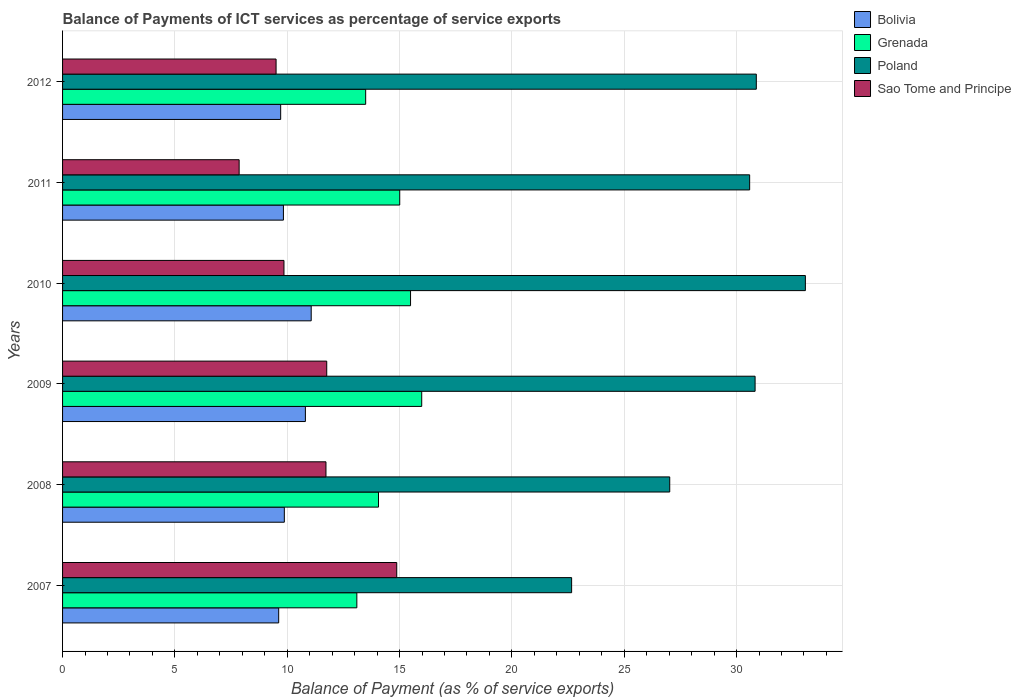How many different coloured bars are there?
Make the answer very short. 4. How many bars are there on the 2nd tick from the top?
Your answer should be compact. 4. How many bars are there on the 1st tick from the bottom?
Provide a succinct answer. 4. What is the label of the 2nd group of bars from the top?
Provide a short and direct response. 2011. In how many cases, is the number of bars for a given year not equal to the number of legend labels?
Give a very brief answer. 0. What is the balance of payments of ICT services in Grenada in 2010?
Ensure brevity in your answer.  15.49. Across all years, what is the maximum balance of payments of ICT services in Bolivia?
Ensure brevity in your answer.  11.07. Across all years, what is the minimum balance of payments of ICT services in Grenada?
Make the answer very short. 13.1. What is the total balance of payments of ICT services in Poland in the graph?
Offer a terse response. 175.03. What is the difference between the balance of payments of ICT services in Bolivia in 2007 and that in 2012?
Give a very brief answer. -0.09. What is the difference between the balance of payments of ICT services in Sao Tome and Principe in 2009 and the balance of payments of ICT services in Poland in 2011?
Provide a short and direct response. -18.82. What is the average balance of payments of ICT services in Poland per year?
Keep it short and to the point. 29.17. In the year 2008, what is the difference between the balance of payments of ICT services in Poland and balance of payments of ICT services in Bolivia?
Ensure brevity in your answer.  17.15. What is the ratio of the balance of payments of ICT services in Sao Tome and Principe in 2007 to that in 2012?
Your answer should be very brief. 1.57. Is the balance of payments of ICT services in Bolivia in 2010 less than that in 2012?
Your response must be concise. No. What is the difference between the highest and the second highest balance of payments of ICT services in Poland?
Your answer should be compact. 2.18. What is the difference between the highest and the lowest balance of payments of ICT services in Sao Tome and Principe?
Ensure brevity in your answer.  7.01. In how many years, is the balance of payments of ICT services in Poland greater than the average balance of payments of ICT services in Poland taken over all years?
Give a very brief answer. 4. What does the 1st bar from the top in 2007 represents?
Your answer should be compact. Sao Tome and Principe. What does the 2nd bar from the bottom in 2007 represents?
Offer a very short reply. Grenada. Is it the case that in every year, the sum of the balance of payments of ICT services in Poland and balance of payments of ICT services in Grenada is greater than the balance of payments of ICT services in Sao Tome and Principe?
Ensure brevity in your answer.  Yes. Does the graph contain any zero values?
Provide a succinct answer. No. Where does the legend appear in the graph?
Make the answer very short. Top right. How many legend labels are there?
Give a very brief answer. 4. What is the title of the graph?
Offer a terse response. Balance of Payments of ICT services as percentage of service exports. Does "Hong Kong" appear as one of the legend labels in the graph?
Ensure brevity in your answer.  No. What is the label or title of the X-axis?
Provide a short and direct response. Balance of Payment (as % of service exports). What is the label or title of the Y-axis?
Your answer should be compact. Years. What is the Balance of Payment (as % of service exports) in Bolivia in 2007?
Make the answer very short. 9.62. What is the Balance of Payment (as % of service exports) in Grenada in 2007?
Your answer should be very brief. 13.1. What is the Balance of Payment (as % of service exports) in Poland in 2007?
Make the answer very short. 22.66. What is the Balance of Payment (as % of service exports) in Sao Tome and Principe in 2007?
Your response must be concise. 14.87. What is the Balance of Payment (as % of service exports) of Bolivia in 2008?
Provide a succinct answer. 9.87. What is the Balance of Payment (as % of service exports) in Grenada in 2008?
Keep it short and to the point. 14.06. What is the Balance of Payment (as % of service exports) of Poland in 2008?
Provide a succinct answer. 27.02. What is the Balance of Payment (as % of service exports) of Sao Tome and Principe in 2008?
Provide a succinct answer. 11.72. What is the Balance of Payment (as % of service exports) in Bolivia in 2009?
Your response must be concise. 10.81. What is the Balance of Payment (as % of service exports) of Grenada in 2009?
Offer a terse response. 15.99. What is the Balance of Payment (as % of service exports) in Poland in 2009?
Make the answer very short. 30.82. What is the Balance of Payment (as % of service exports) in Sao Tome and Principe in 2009?
Keep it short and to the point. 11.76. What is the Balance of Payment (as % of service exports) of Bolivia in 2010?
Offer a very short reply. 11.07. What is the Balance of Payment (as % of service exports) of Grenada in 2010?
Offer a very short reply. 15.49. What is the Balance of Payment (as % of service exports) of Poland in 2010?
Your answer should be compact. 33.06. What is the Balance of Payment (as % of service exports) of Sao Tome and Principe in 2010?
Offer a very short reply. 9.85. What is the Balance of Payment (as % of service exports) in Bolivia in 2011?
Ensure brevity in your answer.  9.83. What is the Balance of Payment (as % of service exports) in Grenada in 2011?
Make the answer very short. 15.01. What is the Balance of Payment (as % of service exports) of Poland in 2011?
Your answer should be compact. 30.58. What is the Balance of Payment (as % of service exports) of Sao Tome and Principe in 2011?
Provide a short and direct response. 7.86. What is the Balance of Payment (as % of service exports) in Bolivia in 2012?
Offer a terse response. 9.71. What is the Balance of Payment (as % of service exports) in Grenada in 2012?
Your answer should be very brief. 13.49. What is the Balance of Payment (as % of service exports) of Poland in 2012?
Offer a very short reply. 30.88. What is the Balance of Payment (as % of service exports) of Sao Tome and Principe in 2012?
Keep it short and to the point. 9.5. Across all years, what is the maximum Balance of Payment (as % of service exports) in Bolivia?
Your answer should be very brief. 11.07. Across all years, what is the maximum Balance of Payment (as % of service exports) in Grenada?
Ensure brevity in your answer.  15.99. Across all years, what is the maximum Balance of Payment (as % of service exports) in Poland?
Offer a terse response. 33.06. Across all years, what is the maximum Balance of Payment (as % of service exports) in Sao Tome and Principe?
Provide a succinct answer. 14.87. Across all years, what is the minimum Balance of Payment (as % of service exports) in Bolivia?
Your response must be concise. 9.62. Across all years, what is the minimum Balance of Payment (as % of service exports) in Grenada?
Ensure brevity in your answer.  13.1. Across all years, what is the minimum Balance of Payment (as % of service exports) in Poland?
Offer a very short reply. 22.66. Across all years, what is the minimum Balance of Payment (as % of service exports) of Sao Tome and Principe?
Provide a succinct answer. 7.86. What is the total Balance of Payment (as % of service exports) in Bolivia in the graph?
Provide a succinct answer. 60.9. What is the total Balance of Payment (as % of service exports) in Grenada in the graph?
Provide a succinct answer. 87.13. What is the total Balance of Payment (as % of service exports) of Poland in the graph?
Offer a very short reply. 175.03. What is the total Balance of Payment (as % of service exports) in Sao Tome and Principe in the graph?
Offer a very short reply. 65.57. What is the difference between the Balance of Payment (as % of service exports) of Bolivia in 2007 and that in 2008?
Ensure brevity in your answer.  -0.25. What is the difference between the Balance of Payment (as % of service exports) in Grenada in 2007 and that in 2008?
Your response must be concise. -0.96. What is the difference between the Balance of Payment (as % of service exports) in Poland in 2007 and that in 2008?
Ensure brevity in your answer.  -4.37. What is the difference between the Balance of Payment (as % of service exports) of Sao Tome and Principe in 2007 and that in 2008?
Give a very brief answer. 3.15. What is the difference between the Balance of Payment (as % of service exports) in Bolivia in 2007 and that in 2009?
Provide a short and direct response. -1.19. What is the difference between the Balance of Payment (as % of service exports) of Grenada in 2007 and that in 2009?
Offer a terse response. -2.89. What is the difference between the Balance of Payment (as % of service exports) in Poland in 2007 and that in 2009?
Your answer should be compact. -8.17. What is the difference between the Balance of Payment (as % of service exports) of Sao Tome and Principe in 2007 and that in 2009?
Ensure brevity in your answer.  3.12. What is the difference between the Balance of Payment (as % of service exports) of Bolivia in 2007 and that in 2010?
Ensure brevity in your answer.  -1.45. What is the difference between the Balance of Payment (as % of service exports) of Grenada in 2007 and that in 2010?
Your answer should be compact. -2.39. What is the difference between the Balance of Payment (as % of service exports) of Poland in 2007 and that in 2010?
Give a very brief answer. -10.4. What is the difference between the Balance of Payment (as % of service exports) of Sao Tome and Principe in 2007 and that in 2010?
Give a very brief answer. 5.02. What is the difference between the Balance of Payment (as % of service exports) of Bolivia in 2007 and that in 2011?
Offer a very short reply. -0.21. What is the difference between the Balance of Payment (as % of service exports) in Grenada in 2007 and that in 2011?
Offer a very short reply. -1.91. What is the difference between the Balance of Payment (as % of service exports) in Poland in 2007 and that in 2011?
Provide a short and direct response. -7.92. What is the difference between the Balance of Payment (as % of service exports) in Sao Tome and Principe in 2007 and that in 2011?
Keep it short and to the point. 7.01. What is the difference between the Balance of Payment (as % of service exports) of Bolivia in 2007 and that in 2012?
Your answer should be compact. -0.09. What is the difference between the Balance of Payment (as % of service exports) of Grenada in 2007 and that in 2012?
Keep it short and to the point. -0.39. What is the difference between the Balance of Payment (as % of service exports) of Poland in 2007 and that in 2012?
Your answer should be compact. -8.22. What is the difference between the Balance of Payment (as % of service exports) in Sao Tome and Principe in 2007 and that in 2012?
Keep it short and to the point. 5.37. What is the difference between the Balance of Payment (as % of service exports) of Bolivia in 2008 and that in 2009?
Give a very brief answer. -0.94. What is the difference between the Balance of Payment (as % of service exports) of Grenada in 2008 and that in 2009?
Offer a terse response. -1.92. What is the difference between the Balance of Payment (as % of service exports) of Poland in 2008 and that in 2009?
Provide a succinct answer. -3.8. What is the difference between the Balance of Payment (as % of service exports) in Sao Tome and Principe in 2008 and that in 2009?
Give a very brief answer. -0.03. What is the difference between the Balance of Payment (as % of service exports) in Bolivia in 2008 and that in 2010?
Your answer should be very brief. -1.2. What is the difference between the Balance of Payment (as % of service exports) in Grenada in 2008 and that in 2010?
Your answer should be compact. -1.43. What is the difference between the Balance of Payment (as % of service exports) of Poland in 2008 and that in 2010?
Your answer should be very brief. -6.04. What is the difference between the Balance of Payment (as % of service exports) in Sao Tome and Principe in 2008 and that in 2010?
Provide a succinct answer. 1.87. What is the difference between the Balance of Payment (as % of service exports) of Bolivia in 2008 and that in 2011?
Keep it short and to the point. 0.04. What is the difference between the Balance of Payment (as % of service exports) of Grenada in 2008 and that in 2011?
Your answer should be very brief. -0.94. What is the difference between the Balance of Payment (as % of service exports) of Poland in 2008 and that in 2011?
Ensure brevity in your answer.  -3.56. What is the difference between the Balance of Payment (as % of service exports) of Sao Tome and Principe in 2008 and that in 2011?
Provide a short and direct response. 3.86. What is the difference between the Balance of Payment (as % of service exports) of Bolivia in 2008 and that in 2012?
Provide a short and direct response. 0.16. What is the difference between the Balance of Payment (as % of service exports) in Grenada in 2008 and that in 2012?
Give a very brief answer. 0.57. What is the difference between the Balance of Payment (as % of service exports) in Poland in 2008 and that in 2012?
Keep it short and to the point. -3.85. What is the difference between the Balance of Payment (as % of service exports) of Sao Tome and Principe in 2008 and that in 2012?
Provide a succinct answer. 2.22. What is the difference between the Balance of Payment (as % of service exports) in Bolivia in 2009 and that in 2010?
Your answer should be compact. -0.26. What is the difference between the Balance of Payment (as % of service exports) in Grenada in 2009 and that in 2010?
Give a very brief answer. 0.5. What is the difference between the Balance of Payment (as % of service exports) of Poland in 2009 and that in 2010?
Give a very brief answer. -2.24. What is the difference between the Balance of Payment (as % of service exports) in Sao Tome and Principe in 2009 and that in 2010?
Provide a succinct answer. 1.9. What is the difference between the Balance of Payment (as % of service exports) of Bolivia in 2009 and that in 2011?
Keep it short and to the point. 0.98. What is the difference between the Balance of Payment (as % of service exports) in Grenada in 2009 and that in 2011?
Give a very brief answer. 0.98. What is the difference between the Balance of Payment (as % of service exports) of Poland in 2009 and that in 2011?
Your answer should be compact. 0.24. What is the difference between the Balance of Payment (as % of service exports) of Sao Tome and Principe in 2009 and that in 2011?
Provide a short and direct response. 3.9. What is the difference between the Balance of Payment (as % of service exports) of Bolivia in 2009 and that in 2012?
Your response must be concise. 1.1. What is the difference between the Balance of Payment (as % of service exports) of Grenada in 2009 and that in 2012?
Offer a very short reply. 2.49. What is the difference between the Balance of Payment (as % of service exports) of Poland in 2009 and that in 2012?
Provide a succinct answer. -0.05. What is the difference between the Balance of Payment (as % of service exports) of Sao Tome and Principe in 2009 and that in 2012?
Make the answer very short. 2.25. What is the difference between the Balance of Payment (as % of service exports) in Bolivia in 2010 and that in 2011?
Your answer should be compact. 1.24. What is the difference between the Balance of Payment (as % of service exports) of Grenada in 2010 and that in 2011?
Your answer should be compact. 0.48. What is the difference between the Balance of Payment (as % of service exports) of Poland in 2010 and that in 2011?
Provide a succinct answer. 2.48. What is the difference between the Balance of Payment (as % of service exports) of Sao Tome and Principe in 2010 and that in 2011?
Ensure brevity in your answer.  1.99. What is the difference between the Balance of Payment (as % of service exports) of Bolivia in 2010 and that in 2012?
Offer a very short reply. 1.36. What is the difference between the Balance of Payment (as % of service exports) in Grenada in 2010 and that in 2012?
Offer a terse response. 2. What is the difference between the Balance of Payment (as % of service exports) in Poland in 2010 and that in 2012?
Keep it short and to the point. 2.18. What is the difference between the Balance of Payment (as % of service exports) of Sao Tome and Principe in 2010 and that in 2012?
Give a very brief answer. 0.35. What is the difference between the Balance of Payment (as % of service exports) of Bolivia in 2011 and that in 2012?
Ensure brevity in your answer.  0.12. What is the difference between the Balance of Payment (as % of service exports) in Grenada in 2011 and that in 2012?
Provide a short and direct response. 1.52. What is the difference between the Balance of Payment (as % of service exports) of Poland in 2011 and that in 2012?
Your answer should be very brief. -0.3. What is the difference between the Balance of Payment (as % of service exports) in Sao Tome and Principe in 2011 and that in 2012?
Your response must be concise. -1.64. What is the difference between the Balance of Payment (as % of service exports) of Bolivia in 2007 and the Balance of Payment (as % of service exports) of Grenada in 2008?
Keep it short and to the point. -4.44. What is the difference between the Balance of Payment (as % of service exports) of Bolivia in 2007 and the Balance of Payment (as % of service exports) of Poland in 2008?
Ensure brevity in your answer.  -17.4. What is the difference between the Balance of Payment (as % of service exports) of Bolivia in 2007 and the Balance of Payment (as % of service exports) of Sao Tome and Principe in 2008?
Offer a very short reply. -2.1. What is the difference between the Balance of Payment (as % of service exports) in Grenada in 2007 and the Balance of Payment (as % of service exports) in Poland in 2008?
Your answer should be compact. -13.93. What is the difference between the Balance of Payment (as % of service exports) of Grenada in 2007 and the Balance of Payment (as % of service exports) of Sao Tome and Principe in 2008?
Make the answer very short. 1.37. What is the difference between the Balance of Payment (as % of service exports) in Poland in 2007 and the Balance of Payment (as % of service exports) in Sao Tome and Principe in 2008?
Your response must be concise. 10.93. What is the difference between the Balance of Payment (as % of service exports) of Bolivia in 2007 and the Balance of Payment (as % of service exports) of Grenada in 2009?
Ensure brevity in your answer.  -6.37. What is the difference between the Balance of Payment (as % of service exports) of Bolivia in 2007 and the Balance of Payment (as % of service exports) of Poland in 2009?
Your answer should be compact. -21.2. What is the difference between the Balance of Payment (as % of service exports) in Bolivia in 2007 and the Balance of Payment (as % of service exports) in Sao Tome and Principe in 2009?
Make the answer very short. -2.14. What is the difference between the Balance of Payment (as % of service exports) of Grenada in 2007 and the Balance of Payment (as % of service exports) of Poland in 2009?
Your response must be concise. -17.73. What is the difference between the Balance of Payment (as % of service exports) in Grenada in 2007 and the Balance of Payment (as % of service exports) in Sao Tome and Principe in 2009?
Your answer should be very brief. 1.34. What is the difference between the Balance of Payment (as % of service exports) of Poland in 2007 and the Balance of Payment (as % of service exports) of Sao Tome and Principe in 2009?
Offer a very short reply. 10.9. What is the difference between the Balance of Payment (as % of service exports) in Bolivia in 2007 and the Balance of Payment (as % of service exports) in Grenada in 2010?
Ensure brevity in your answer.  -5.87. What is the difference between the Balance of Payment (as % of service exports) in Bolivia in 2007 and the Balance of Payment (as % of service exports) in Poland in 2010?
Offer a very short reply. -23.44. What is the difference between the Balance of Payment (as % of service exports) of Bolivia in 2007 and the Balance of Payment (as % of service exports) of Sao Tome and Principe in 2010?
Offer a very short reply. -0.23. What is the difference between the Balance of Payment (as % of service exports) in Grenada in 2007 and the Balance of Payment (as % of service exports) in Poland in 2010?
Make the answer very short. -19.96. What is the difference between the Balance of Payment (as % of service exports) of Grenada in 2007 and the Balance of Payment (as % of service exports) of Sao Tome and Principe in 2010?
Give a very brief answer. 3.24. What is the difference between the Balance of Payment (as % of service exports) in Poland in 2007 and the Balance of Payment (as % of service exports) in Sao Tome and Principe in 2010?
Offer a terse response. 12.8. What is the difference between the Balance of Payment (as % of service exports) of Bolivia in 2007 and the Balance of Payment (as % of service exports) of Grenada in 2011?
Ensure brevity in your answer.  -5.39. What is the difference between the Balance of Payment (as % of service exports) in Bolivia in 2007 and the Balance of Payment (as % of service exports) in Poland in 2011?
Keep it short and to the point. -20.96. What is the difference between the Balance of Payment (as % of service exports) of Bolivia in 2007 and the Balance of Payment (as % of service exports) of Sao Tome and Principe in 2011?
Make the answer very short. 1.76. What is the difference between the Balance of Payment (as % of service exports) in Grenada in 2007 and the Balance of Payment (as % of service exports) in Poland in 2011?
Provide a short and direct response. -17.48. What is the difference between the Balance of Payment (as % of service exports) in Grenada in 2007 and the Balance of Payment (as % of service exports) in Sao Tome and Principe in 2011?
Offer a terse response. 5.24. What is the difference between the Balance of Payment (as % of service exports) in Poland in 2007 and the Balance of Payment (as % of service exports) in Sao Tome and Principe in 2011?
Keep it short and to the point. 14.8. What is the difference between the Balance of Payment (as % of service exports) in Bolivia in 2007 and the Balance of Payment (as % of service exports) in Grenada in 2012?
Give a very brief answer. -3.87. What is the difference between the Balance of Payment (as % of service exports) in Bolivia in 2007 and the Balance of Payment (as % of service exports) in Poland in 2012?
Give a very brief answer. -21.26. What is the difference between the Balance of Payment (as % of service exports) in Bolivia in 2007 and the Balance of Payment (as % of service exports) in Sao Tome and Principe in 2012?
Offer a very short reply. 0.12. What is the difference between the Balance of Payment (as % of service exports) in Grenada in 2007 and the Balance of Payment (as % of service exports) in Poland in 2012?
Offer a terse response. -17.78. What is the difference between the Balance of Payment (as % of service exports) of Grenada in 2007 and the Balance of Payment (as % of service exports) of Sao Tome and Principe in 2012?
Give a very brief answer. 3.59. What is the difference between the Balance of Payment (as % of service exports) of Poland in 2007 and the Balance of Payment (as % of service exports) of Sao Tome and Principe in 2012?
Keep it short and to the point. 13.15. What is the difference between the Balance of Payment (as % of service exports) in Bolivia in 2008 and the Balance of Payment (as % of service exports) in Grenada in 2009?
Your answer should be very brief. -6.12. What is the difference between the Balance of Payment (as % of service exports) of Bolivia in 2008 and the Balance of Payment (as % of service exports) of Poland in 2009?
Keep it short and to the point. -20.95. What is the difference between the Balance of Payment (as % of service exports) of Bolivia in 2008 and the Balance of Payment (as % of service exports) of Sao Tome and Principe in 2009?
Offer a terse response. -1.89. What is the difference between the Balance of Payment (as % of service exports) of Grenada in 2008 and the Balance of Payment (as % of service exports) of Poland in 2009?
Provide a succinct answer. -16.76. What is the difference between the Balance of Payment (as % of service exports) of Grenada in 2008 and the Balance of Payment (as % of service exports) of Sao Tome and Principe in 2009?
Provide a succinct answer. 2.3. What is the difference between the Balance of Payment (as % of service exports) of Poland in 2008 and the Balance of Payment (as % of service exports) of Sao Tome and Principe in 2009?
Make the answer very short. 15.27. What is the difference between the Balance of Payment (as % of service exports) in Bolivia in 2008 and the Balance of Payment (as % of service exports) in Grenada in 2010?
Keep it short and to the point. -5.62. What is the difference between the Balance of Payment (as % of service exports) of Bolivia in 2008 and the Balance of Payment (as % of service exports) of Poland in 2010?
Keep it short and to the point. -23.19. What is the difference between the Balance of Payment (as % of service exports) of Bolivia in 2008 and the Balance of Payment (as % of service exports) of Sao Tome and Principe in 2010?
Offer a very short reply. 0.02. What is the difference between the Balance of Payment (as % of service exports) in Grenada in 2008 and the Balance of Payment (as % of service exports) in Poland in 2010?
Your answer should be compact. -19. What is the difference between the Balance of Payment (as % of service exports) of Grenada in 2008 and the Balance of Payment (as % of service exports) of Sao Tome and Principe in 2010?
Provide a succinct answer. 4.21. What is the difference between the Balance of Payment (as % of service exports) in Poland in 2008 and the Balance of Payment (as % of service exports) in Sao Tome and Principe in 2010?
Provide a succinct answer. 17.17. What is the difference between the Balance of Payment (as % of service exports) of Bolivia in 2008 and the Balance of Payment (as % of service exports) of Grenada in 2011?
Keep it short and to the point. -5.14. What is the difference between the Balance of Payment (as % of service exports) of Bolivia in 2008 and the Balance of Payment (as % of service exports) of Poland in 2011?
Provide a short and direct response. -20.71. What is the difference between the Balance of Payment (as % of service exports) in Bolivia in 2008 and the Balance of Payment (as % of service exports) in Sao Tome and Principe in 2011?
Offer a very short reply. 2.01. What is the difference between the Balance of Payment (as % of service exports) in Grenada in 2008 and the Balance of Payment (as % of service exports) in Poland in 2011?
Your response must be concise. -16.52. What is the difference between the Balance of Payment (as % of service exports) in Grenada in 2008 and the Balance of Payment (as % of service exports) in Sao Tome and Principe in 2011?
Give a very brief answer. 6.2. What is the difference between the Balance of Payment (as % of service exports) of Poland in 2008 and the Balance of Payment (as % of service exports) of Sao Tome and Principe in 2011?
Your answer should be compact. 19.17. What is the difference between the Balance of Payment (as % of service exports) in Bolivia in 2008 and the Balance of Payment (as % of service exports) in Grenada in 2012?
Offer a very short reply. -3.62. What is the difference between the Balance of Payment (as % of service exports) of Bolivia in 2008 and the Balance of Payment (as % of service exports) of Poland in 2012?
Your answer should be compact. -21.01. What is the difference between the Balance of Payment (as % of service exports) of Bolivia in 2008 and the Balance of Payment (as % of service exports) of Sao Tome and Principe in 2012?
Ensure brevity in your answer.  0.37. What is the difference between the Balance of Payment (as % of service exports) of Grenada in 2008 and the Balance of Payment (as % of service exports) of Poland in 2012?
Keep it short and to the point. -16.82. What is the difference between the Balance of Payment (as % of service exports) of Grenada in 2008 and the Balance of Payment (as % of service exports) of Sao Tome and Principe in 2012?
Offer a terse response. 4.56. What is the difference between the Balance of Payment (as % of service exports) of Poland in 2008 and the Balance of Payment (as % of service exports) of Sao Tome and Principe in 2012?
Provide a short and direct response. 17.52. What is the difference between the Balance of Payment (as % of service exports) of Bolivia in 2009 and the Balance of Payment (as % of service exports) of Grenada in 2010?
Your answer should be very brief. -4.68. What is the difference between the Balance of Payment (as % of service exports) of Bolivia in 2009 and the Balance of Payment (as % of service exports) of Poland in 2010?
Provide a short and direct response. -22.25. What is the difference between the Balance of Payment (as % of service exports) in Bolivia in 2009 and the Balance of Payment (as % of service exports) in Sao Tome and Principe in 2010?
Keep it short and to the point. 0.95. What is the difference between the Balance of Payment (as % of service exports) of Grenada in 2009 and the Balance of Payment (as % of service exports) of Poland in 2010?
Your answer should be very brief. -17.08. What is the difference between the Balance of Payment (as % of service exports) of Grenada in 2009 and the Balance of Payment (as % of service exports) of Sao Tome and Principe in 2010?
Offer a terse response. 6.13. What is the difference between the Balance of Payment (as % of service exports) in Poland in 2009 and the Balance of Payment (as % of service exports) in Sao Tome and Principe in 2010?
Ensure brevity in your answer.  20.97. What is the difference between the Balance of Payment (as % of service exports) in Bolivia in 2009 and the Balance of Payment (as % of service exports) in Grenada in 2011?
Your answer should be compact. -4.2. What is the difference between the Balance of Payment (as % of service exports) in Bolivia in 2009 and the Balance of Payment (as % of service exports) in Poland in 2011?
Provide a short and direct response. -19.77. What is the difference between the Balance of Payment (as % of service exports) in Bolivia in 2009 and the Balance of Payment (as % of service exports) in Sao Tome and Principe in 2011?
Keep it short and to the point. 2.95. What is the difference between the Balance of Payment (as % of service exports) of Grenada in 2009 and the Balance of Payment (as % of service exports) of Poland in 2011?
Your answer should be very brief. -14.6. What is the difference between the Balance of Payment (as % of service exports) in Grenada in 2009 and the Balance of Payment (as % of service exports) in Sao Tome and Principe in 2011?
Your answer should be very brief. 8.13. What is the difference between the Balance of Payment (as % of service exports) in Poland in 2009 and the Balance of Payment (as % of service exports) in Sao Tome and Principe in 2011?
Keep it short and to the point. 22.96. What is the difference between the Balance of Payment (as % of service exports) of Bolivia in 2009 and the Balance of Payment (as % of service exports) of Grenada in 2012?
Provide a succinct answer. -2.68. What is the difference between the Balance of Payment (as % of service exports) in Bolivia in 2009 and the Balance of Payment (as % of service exports) in Poland in 2012?
Offer a terse response. -20.07. What is the difference between the Balance of Payment (as % of service exports) in Bolivia in 2009 and the Balance of Payment (as % of service exports) in Sao Tome and Principe in 2012?
Offer a terse response. 1.3. What is the difference between the Balance of Payment (as % of service exports) of Grenada in 2009 and the Balance of Payment (as % of service exports) of Poland in 2012?
Provide a short and direct response. -14.89. What is the difference between the Balance of Payment (as % of service exports) of Grenada in 2009 and the Balance of Payment (as % of service exports) of Sao Tome and Principe in 2012?
Make the answer very short. 6.48. What is the difference between the Balance of Payment (as % of service exports) of Poland in 2009 and the Balance of Payment (as % of service exports) of Sao Tome and Principe in 2012?
Ensure brevity in your answer.  21.32. What is the difference between the Balance of Payment (as % of service exports) of Bolivia in 2010 and the Balance of Payment (as % of service exports) of Grenada in 2011?
Your response must be concise. -3.94. What is the difference between the Balance of Payment (as % of service exports) in Bolivia in 2010 and the Balance of Payment (as % of service exports) in Poland in 2011?
Provide a succinct answer. -19.52. What is the difference between the Balance of Payment (as % of service exports) of Bolivia in 2010 and the Balance of Payment (as % of service exports) of Sao Tome and Principe in 2011?
Ensure brevity in your answer.  3.21. What is the difference between the Balance of Payment (as % of service exports) in Grenada in 2010 and the Balance of Payment (as % of service exports) in Poland in 2011?
Ensure brevity in your answer.  -15.09. What is the difference between the Balance of Payment (as % of service exports) of Grenada in 2010 and the Balance of Payment (as % of service exports) of Sao Tome and Principe in 2011?
Provide a short and direct response. 7.63. What is the difference between the Balance of Payment (as % of service exports) of Poland in 2010 and the Balance of Payment (as % of service exports) of Sao Tome and Principe in 2011?
Provide a short and direct response. 25.2. What is the difference between the Balance of Payment (as % of service exports) in Bolivia in 2010 and the Balance of Payment (as % of service exports) in Grenada in 2012?
Provide a short and direct response. -2.42. What is the difference between the Balance of Payment (as % of service exports) in Bolivia in 2010 and the Balance of Payment (as % of service exports) in Poland in 2012?
Offer a terse response. -19.81. What is the difference between the Balance of Payment (as % of service exports) of Bolivia in 2010 and the Balance of Payment (as % of service exports) of Sao Tome and Principe in 2012?
Your answer should be very brief. 1.56. What is the difference between the Balance of Payment (as % of service exports) of Grenada in 2010 and the Balance of Payment (as % of service exports) of Poland in 2012?
Provide a short and direct response. -15.39. What is the difference between the Balance of Payment (as % of service exports) of Grenada in 2010 and the Balance of Payment (as % of service exports) of Sao Tome and Principe in 2012?
Offer a terse response. 5.98. What is the difference between the Balance of Payment (as % of service exports) in Poland in 2010 and the Balance of Payment (as % of service exports) in Sao Tome and Principe in 2012?
Your answer should be compact. 23.56. What is the difference between the Balance of Payment (as % of service exports) in Bolivia in 2011 and the Balance of Payment (as % of service exports) in Grenada in 2012?
Your answer should be very brief. -3.66. What is the difference between the Balance of Payment (as % of service exports) of Bolivia in 2011 and the Balance of Payment (as % of service exports) of Poland in 2012?
Provide a short and direct response. -21.05. What is the difference between the Balance of Payment (as % of service exports) of Bolivia in 2011 and the Balance of Payment (as % of service exports) of Sao Tome and Principe in 2012?
Give a very brief answer. 0.33. What is the difference between the Balance of Payment (as % of service exports) in Grenada in 2011 and the Balance of Payment (as % of service exports) in Poland in 2012?
Keep it short and to the point. -15.87. What is the difference between the Balance of Payment (as % of service exports) of Grenada in 2011 and the Balance of Payment (as % of service exports) of Sao Tome and Principe in 2012?
Provide a short and direct response. 5.5. What is the difference between the Balance of Payment (as % of service exports) of Poland in 2011 and the Balance of Payment (as % of service exports) of Sao Tome and Principe in 2012?
Your response must be concise. 21.08. What is the average Balance of Payment (as % of service exports) of Bolivia per year?
Provide a succinct answer. 10.15. What is the average Balance of Payment (as % of service exports) of Grenada per year?
Give a very brief answer. 14.52. What is the average Balance of Payment (as % of service exports) of Poland per year?
Keep it short and to the point. 29.17. What is the average Balance of Payment (as % of service exports) of Sao Tome and Principe per year?
Provide a short and direct response. 10.93. In the year 2007, what is the difference between the Balance of Payment (as % of service exports) in Bolivia and Balance of Payment (as % of service exports) in Grenada?
Make the answer very short. -3.48. In the year 2007, what is the difference between the Balance of Payment (as % of service exports) of Bolivia and Balance of Payment (as % of service exports) of Poland?
Offer a terse response. -13.04. In the year 2007, what is the difference between the Balance of Payment (as % of service exports) in Bolivia and Balance of Payment (as % of service exports) in Sao Tome and Principe?
Ensure brevity in your answer.  -5.25. In the year 2007, what is the difference between the Balance of Payment (as % of service exports) of Grenada and Balance of Payment (as % of service exports) of Poland?
Ensure brevity in your answer.  -9.56. In the year 2007, what is the difference between the Balance of Payment (as % of service exports) in Grenada and Balance of Payment (as % of service exports) in Sao Tome and Principe?
Make the answer very short. -1.77. In the year 2007, what is the difference between the Balance of Payment (as % of service exports) of Poland and Balance of Payment (as % of service exports) of Sao Tome and Principe?
Offer a very short reply. 7.79. In the year 2008, what is the difference between the Balance of Payment (as % of service exports) of Bolivia and Balance of Payment (as % of service exports) of Grenada?
Keep it short and to the point. -4.19. In the year 2008, what is the difference between the Balance of Payment (as % of service exports) of Bolivia and Balance of Payment (as % of service exports) of Poland?
Provide a short and direct response. -17.15. In the year 2008, what is the difference between the Balance of Payment (as % of service exports) of Bolivia and Balance of Payment (as % of service exports) of Sao Tome and Principe?
Give a very brief answer. -1.85. In the year 2008, what is the difference between the Balance of Payment (as % of service exports) of Grenada and Balance of Payment (as % of service exports) of Poland?
Your answer should be very brief. -12.96. In the year 2008, what is the difference between the Balance of Payment (as % of service exports) of Grenada and Balance of Payment (as % of service exports) of Sao Tome and Principe?
Your answer should be compact. 2.34. In the year 2008, what is the difference between the Balance of Payment (as % of service exports) in Poland and Balance of Payment (as % of service exports) in Sao Tome and Principe?
Your answer should be very brief. 15.3. In the year 2009, what is the difference between the Balance of Payment (as % of service exports) in Bolivia and Balance of Payment (as % of service exports) in Grenada?
Offer a very short reply. -5.18. In the year 2009, what is the difference between the Balance of Payment (as % of service exports) of Bolivia and Balance of Payment (as % of service exports) of Poland?
Your answer should be very brief. -20.02. In the year 2009, what is the difference between the Balance of Payment (as % of service exports) in Bolivia and Balance of Payment (as % of service exports) in Sao Tome and Principe?
Offer a very short reply. -0.95. In the year 2009, what is the difference between the Balance of Payment (as % of service exports) in Grenada and Balance of Payment (as % of service exports) in Poland?
Make the answer very short. -14.84. In the year 2009, what is the difference between the Balance of Payment (as % of service exports) of Grenada and Balance of Payment (as % of service exports) of Sao Tome and Principe?
Your response must be concise. 4.23. In the year 2009, what is the difference between the Balance of Payment (as % of service exports) in Poland and Balance of Payment (as % of service exports) in Sao Tome and Principe?
Provide a succinct answer. 19.07. In the year 2010, what is the difference between the Balance of Payment (as % of service exports) of Bolivia and Balance of Payment (as % of service exports) of Grenada?
Provide a short and direct response. -4.42. In the year 2010, what is the difference between the Balance of Payment (as % of service exports) in Bolivia and Balance of Payment (as % of service exports) in Poland?
Make the answer very short. -21.99. In the year 2010, what is the difference between the Balance of Payment (as % of service exports) of Bolivia and Balance of Payment (as % of service exports) of Sao Tome and Principe?
Provide a succinct answer. 1.21. In the year 2010, what is the difference between the Balance of Payment (as % of service exports) in Grenada and Balance of Payment (as % of service exports) in Poland?
Keep it short and to the point. -17.57. In the year 2010, what is the difference between the Balance of Payment (as % of service exports) in Grenada and Balance of Payment (as % of service exports) in Sao Tome and Principe?
Your response must be concise. 5.63. In the year 2010, what is the difference between the Balance of Payment (as % of service exports) in Poland and Balance of Payment (as % of service exports) in Sao Tome and Principe?
Your response must be concise. 23.21. In the year 2011, what is the difference between the Balance of Payment (as % of service exports) in Bolivia and Balance of Payment (as % of service exports) in Grenada?
Provide a succinct answer. -5.18. In the year 2011, what is the difference between the Balance of Payment (as % of service exports) of Bolivia and Balance of Payment (as % of service exports) of Poland?
Offer a very short reply. -20.75. In the year 2011, what is the difference between the Balance of Payment (as % of service exports) in Bolivia and Balance of Payment (as % of service exports) in Sao Tome and Principe?
Offer a terse response. 1.97. In the year 2011, what is the difference between the Balance of Payment (as % of service exports) in Grenada and Balance of Payment (as % of service exports) in Poland?
Give a very brief answer. -15.57. In the year 2011, what is the difference between the Balance of Payment (as % of service exports) of Grenada and Balance of Payment (as % of service exports) of Sao Tome and Principe?
Offer a terse response. 7.15. In the year 2011, what is the difference between the Balance of Payment (as % of service exports) in Poland and Balance of Payment (as % of service exports) in Sao Tome and Principe?
Provide a short and direct response. 22.72. In the year 2012, what is the difference between the Balance of Payment (as % of service exports) in Bolivia and Balance of Payment (as % of service exports) in Grenada?
Your response must be concise. -3.78. In the year 2012, what is the difference between the Balance of Payment (as % of service exports) in Bolivia and Balance of Payment (as % of service exports) in Poland?
Make the answer very short. -21.17. In the year 2012, what is the difference between the Balance of Payment (as % of service exports) of Bolivia and Balance of Payment (as % of service exports) of Sao Tome and Principe?
Offer a terse response. 0.2. In the year 2012, what is the difference between the Balance of Payment (as % of service exports) in Grenada and Balance of Payment (as % of service exports) in Poland?
Ensure brevity in your answer.  -17.39. In the year 2012, what is the difference between the Balance of Payment (as % of service exports) of Grenada and Balance of Payment (as % of service exports) of Sao Tome and Principe?
Provide a succinct answer. 3.99. In the year 2012, what is the difference between the Balance of Payment (as % of service exports) of Poland and Balance of Payment (as % of service exports) of Sao Tome and Principe?
Your answer should be compact. 21.37. What is the ratio of the Balance of Payment (as % of service exports) of Bolivia in 2007 to that in 2008?
Provide a short and direct response. 0.97. What is the ratio of the Balance of Payment (as % of service exports) of Grenada in 2007 to that in 2008?
Make the answer very short. 0.93. What is the ratio of the Balance of Payment (as % of service exports) of Poland in 2007 to that in 2008?
Give a very brief answer. 0.84. What is the ratio of the Balance of Payment (as % of service exports) in Sao Tome and Principe in 2007 to that in 2008?
Provide a succinct answer. 1.27. What is the ratio of the Balance of Payment (as % of service exports) in Bolivia in 2007 to that in 2009?
Keep it short and to the point. 0.89. What is the ratio of the Balance of Payment (as % of service exports) of Grenada in 2007 to that in 2009?
Your response must be concise. 0.82. What is the ratio of the Balance of Payment (as % of service exports) of Poland in 2007 to that in 2009?
Keep it short and to the point. 0.74. What is the ratio of the Balance of Payment (as % of service exports) in Sao Tome and Principe in 2007 to that in 2009?
Your answer should be compact. 1.26. What is the ratio of the Balance of Payment (as % of service exports) of Bolivia in 2007 to that in 2010?
Ensure brevity in your answer.  0.87. What is the ratio of the Balance of Payment (as % of service exports) of Grenada in 2007 to that in 2010?
Make the answer very short. 0.85. What is the ratio of the Balance of Payment (as % of service exports) of Poland in 2007 to that in 2010?
Your response must be concise. 0.69. What is the ratio of the Balance of Payment (as % of service exports) of Sao Tome and Principe in 2007 to that in 2010?
Keep it short and to the point. 1.51. What is the ratio of the Balance of Payment (as % of service exports) in Bolivia in 2007 to that in 2011?
Give a very brief answer. 0.98. What is the ratio of the Balance of Payment (as % of service exports) in Grenada in 2007 to that in 2011?
Offer a terse response. 0.87. What is the ratio of the Balance of Payment (as % of service exports) in Poland in 2007 to that in 2011?
Make the answer very short. 0.74. What is the ratio of the Balance of Payment (as % of service exports) in Sao Tome and Principe in 2007 to that in 2011?
Offer a very short reply. 1.89. What is the ratio of the Balance of Payment (as % of service exports) of Bolivia in 2007 to that in 2012?
Give a very brief answer. 0.99. What is the ratio of the Balance of Payment (as % of service exports) of Grenada in 2007 to that in 2012?
Your response must be concise. 0.97. What is the ratio of the Balance of Payment (as % of service exports) of Poland in 2007 to that in 2012?
Your answer should be compact. 0.73. What is the ratio of the Balance of Payment (as % of service exports) of Sao Tome and Principe in 2007 to that in 2012?
Your response must be concise. 1.56. What is the ratio of the Balance of Payment (as % of service exports) of Bolivia in 2008 to that in 2009?
Your answer should be compact. 0.91. What is the ratio of the Balance of Payment (as % of service exports) of Grenada in 2008 to that in 2009?
Keep it short and to the point. 0.88. What is the ratio of the Balance of Payment (as % of service exports) of Poland in 2008 to that in 2009?
Ensure brevity in your answer.  0.88. What is the ratio of the Balance of Payment (as % of service exports) of Sao Tome and Principe in 2008 to that in 2009?
Give a very brief answer. 1. What is the ratio of the Balance of Payment (as % of service exports) in Bolivia in 2008 to that in 2010?
Your response must be concise. 0.89. What is the ratio of the Balance of Payment (as % of service exports) in Grenada in 2008 to that in 2010?
Offer a terse response. 0.91. What is the ratio of the Balance of Payment (as % of service exports) of Poland in 2008 to that in 2010?
Offer a very short reply. 0.82. What is the ratio of the Balance of Payment (as % of service exports) in Sao Tome and Principe in 2008 to that in 2010?
Give a very brief answer. 1.19. What is the ratio of the Balance of Payment (as % of service exports) of Grenada in 2008 to that in 2011?
Your answer should be compact. 0.94. What is the ratio of the Balance of Payment (as % of service exports) in Poland in 2008 to that in 2011?
Offer a very short reply. 0.88. What is the ratio of the Balance of Payment (as % of service exports) of Sao Tome and Principe in 2008 to that in 2011?
Keep it short and to the point. 1.49. What is the ratio of the Balance of Payment (as % of service exports) in Bolivia in 2008 to that in 2012?
Your answer should be compact. 1.02. What is the ratio of the Balance of Payment (as % of service exports) in Grenada in 2008 to that in 2012?
Your response must be concise. 1.04. What is the ratio of the Balance of Payment (as % of service exports) in Poland in 2008 to that in 2012?
Give a very brief answer. 0.88. What is the ratio of the Balance of Payment (as % of service exports) in Sao Tome and Principe in 2008 to that in 2012?
Your answer should be compact. 1.23. What is the ratio of the Balance of Payment (as % of service exports) in Bolivia in 2009 to that in 2010?
Offer a terse response. 0.98. What is the ratio of the Balance of Payment (as % of service exports) in Grenada in 2009 to that in 2010?
Your answer should be compact. 1.03. What is the ratio of the Balance of Payment (as % of service exports) in Poland in 2009 to that in 2010?
Make the answer very short. 0.93. What is the ratio of the Balance of Payment (as % of service exports) in Sao Tome and Principe in 2009 to that in 2010?
Make the answer very short. 1.19. What is the ratio of the Balance of Payment (as % of service exports) in Bolivia in 2009 to that in 2011?
Make the answer very short. 1.1. What is the ratio of the Balance of Payment (as % of service exports) of Grenada in 2009 to that in 2011?
Keep it short and to the point. 1.07. What is the ratio of the Balance of Payment (as % of service exports) of Poland in 2009 to that in 2011?
Ensure brevity in your answer.  1.01. What is the ratio of the Balance of Payment (as % of service exports) in Sao Tome and Principe in 2009 to that in 2011?
Provide a succinct answer. 1.5. What is the ratio of the Balance of Payment (as % of service exports) of Bolivia in 2009 to that in 2012?
Make the answer very short. 1.11. What is the ratio of the Balance of Payment (as % of service exports) in Grenada in 2009 to that in 2012?
Make the answer very short. 1.18. What is the ratio of the Balance of Payment (as % of service exports) of Poland in 2009 to that in 2012?
Keep it short and to the point. 1. What is the ratio of the Balance of Payment (as % of service exports) in Sao Tome and Principe in 2009 to that in 2012?
Make the answer very short. 1.24. What is the ratio of the Balance of Payment (as % of service exports) in Bolivia in 2010 to that in 2011?
Give a very brief answer. 1.13. What is the ratio of the Balance of Payment (as % of service exports) of Grenada in 2010 to that in 2011?
Your answer should be compact. 1.03. What is the ratio of the Balance of Payment (as % of service exports) of Poland in 2010 to that in 2011?
Ensure brevity in your answer.  1.08. What is the ratio of the Balance of Payment (as % of service exports) in Sao Tome and Principe in 2010 to that in 2011?
Offer a very short reply. 1.25. What is the ratio of the Balance of Payment (as % of service exports) in Bolivia in 2010 to that in 2012?
Keep it short and to the point. 1.14. What is the ratio of the Balance of Payment (as % of service exports) in Grenada in 2010 to that in 2012?
Your answer should be very brief. 1.15. What is the ratio of the Balance of Payment (as % of service exports) in Poland in 2010 to that in 2012?
Ensure brevity in your answer.  1.07. What is the ratio of the Balance of Payment (as % of service exports) of Sao Tome and Principe in 2010 to that in 2012?
Make the answer very short. 1.04. What is the ratio of the Balance of Payment (as % of service exports) of Bolivia in 2011 to that in 2012?
Provide a succinct answer. 1.01. What is the ratio of the Balance of Payment (as % of service exports) in Grenada in 2011 to that in 2012?
Provide a short and direct response. 1.11. What is the ratio of the Balance of Payment (as % of service exports) in Poland in 2011 to that in 2012?
Your answer should be very brief. 0.99. What is the ratio of the Balance of Payment (as % of service exports) in Sao Tome and Principe in 2011 to that in 2012?
Provide a short and direct response. 0.83. What is the difference between the highest and the second highest Balance of Payment (as % of service exports) of Bolivia?
Your answer should be compact. 0.26. What is the difference between the highest and the second highest Balance of Payment (as % of service exports) in Grenada?
Offer a very short reply. 0.5. What is the difference between the highest and the second highest Balance of Payment (as % of service exports) of Poland?
Provide a short and direct response. 2.18. What is the difference between the highest and the second highest Balance of Payment (as % of service exports) of Sao Tome and Principe?
Offer a very short reply. 3.12. What is the difference between the highest and the lowest Balance of Payment (as % of service exports) in Bolivia?
Ensure brevity in your answer.  1.45. What is the difference between the highest and the lowest Balance of Payment (as % of service exports) in Grenada?
Provide a short and direct response. 2.89. What is the difference between the highest and the lowest Balance of Payment (as % of service exports) of Poland?
Your answer should be compact. 10.4. What is the difference between the highest and the lowest Balance of Payment (as % of service exports) in Sao Tome and Principe?
Provide a succinct answer. 7.01. 